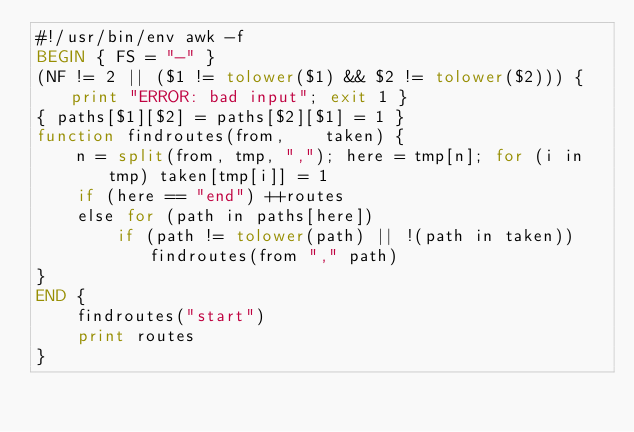<code> <loc_0><loc_0><loc_500><loc_500><_Awk_>#!/usr/bin/env awk -f
BEGIN { FS = "-" }
(NF != 2 || ($1 != tolower($1) && $2 != tolower($2))) { print "ERROR: bad input"; exit 1 }
{ paths[$1][$2] = paths[$2][$1] = 1 }
function findroutes(from,    taken) {
    n = split(from, tmp, ","); here = tmp[n]; for (i in tmp) taken[tmp[i]] = 1
    if (here == "end") ++routes
    else for (path in paths[here])
        if (path != tolower(path) || !(path in taken)) findroutes(from "," path)
}
END {
    findroutes("start")
    print routes
}
</code> 